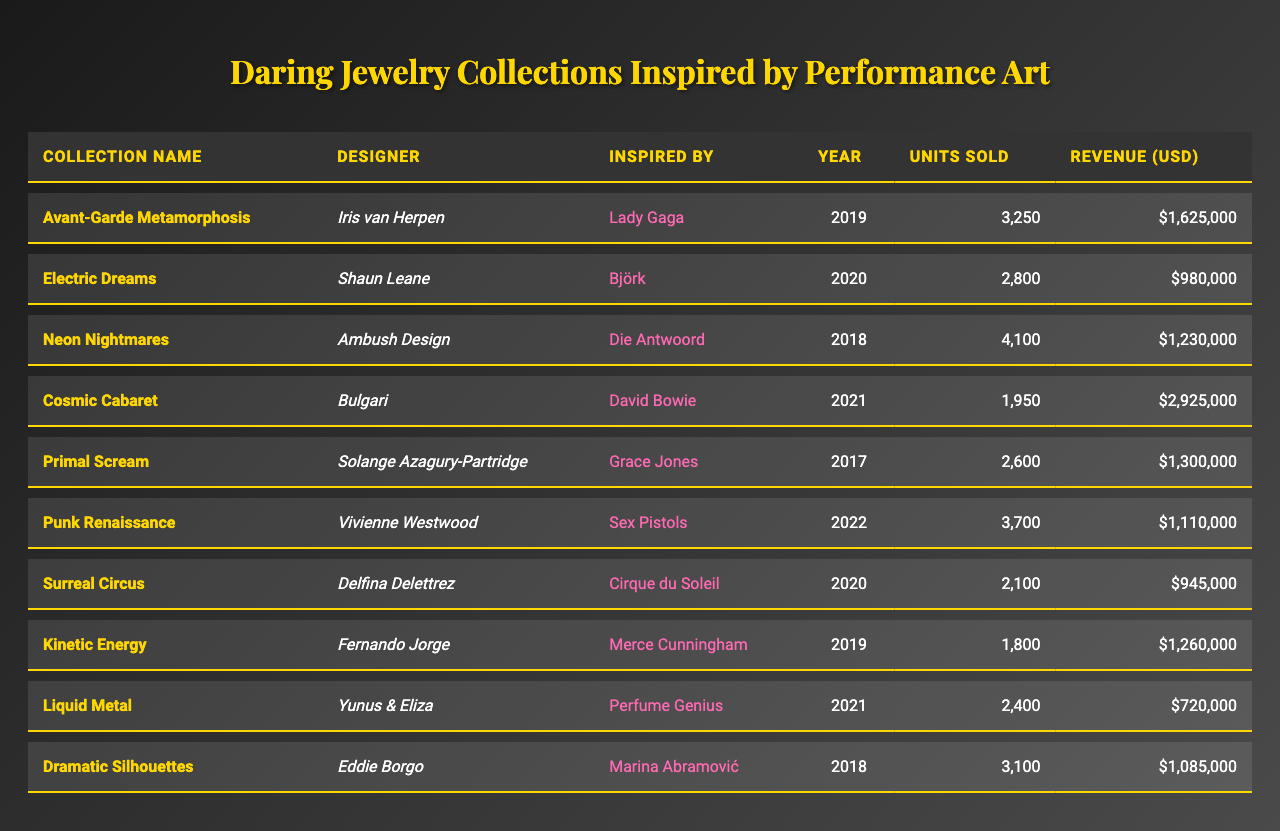What is the revenue generated by the "Electric Dreams" collection? The table indicates that the revenue for the "Electric Dreams" collection is shown in the Revenue (USD) column. Looking at the row for "Electric Dreams," the figure is $980,000.
Answer: $980,000 Which collection had the highest number of units sold? To determine the collection with the highest units sold, we can review the Units Sold column and locate the maximum value. The highest value is 4,100, which is attributed to the "Neon Nightmares" collection.
Answer: "Neon Nightmares" What year was the "Primal Scream" collection released? By examining the Year column corresponding to the "Primal Scream" collection, we can see that it was released in 2017.
Answer: 2017 What is the total revenue from all collections combined? To find the total revenue, we must sum up the revenue figures from all collections: 1,625,000 + 980,000 + 1,230,000 + 2,925,000 + 1,300,000 + 1,110,000 + 945,000 + 1,260,000 + 720,000 + 1,085,000, which totals to 12,200,000.
Answer: $12,200,000 Did any collection inspired by David Bowie sell more than 2,500 units? Checking the Units Sold for the "Cosmic Cabaret" collection, which is inspired by David Bowie, we see it sold 1,950 units, which is less than 2,500. Therefore, the answer is no.
Answer: No What was the average number of units sold across all collections? To find the average, we calculate the total units sold (3,250 + 2,800 + 4,100 + 1,950 + 2,600 + 3,700 + 2,100 + 1,800 + 2,400 + 3,100 = 24,000) and divide by the number of collections (10): 24,000 / 10 = 2,400.
Answer: 2,400 Which designer had the highest revenue collection, and what was the amount? By reviewing the revenue figures, we find that "Cosmic Cabaret" designed by Bulgari generated the highest revenue at $2,925,000.
Answer: Bulgari, $2,925,000 Is there a collection that was inspired by Cirque du Soleil? If so, what was the number of units sold? Yes, the "Surreal Circus" collection is inspired by Cirque du Soleil, and it sold 2,100 units as indicated in the table.
Answer: Yes, 2,100 units What is the total number of units sold by all collections designed by Vivienne Westwood? Vivienne Westwood designed only the "Punk Renaissance" collection, which sold 3,700 units. Thus, the total number of units sold is simply 3,700.
Answer: 3,700 What is the difference in revenue between the "Dramatic Silhouettes" and "Liquid Metal" collections? The revenue for "Dramatic Silhouettes" is $1,085,000, and for "Liquid Metal," it’s $720,000. The difference is $1,085,000 - $720,000 = $365,000.
Answer: $365,000 Which performance artist inspired the collection "Electric Dreams"? According to the table, the "Electric Dreams" collection was inspired by the performance artist Björk.
Answer: Björk 